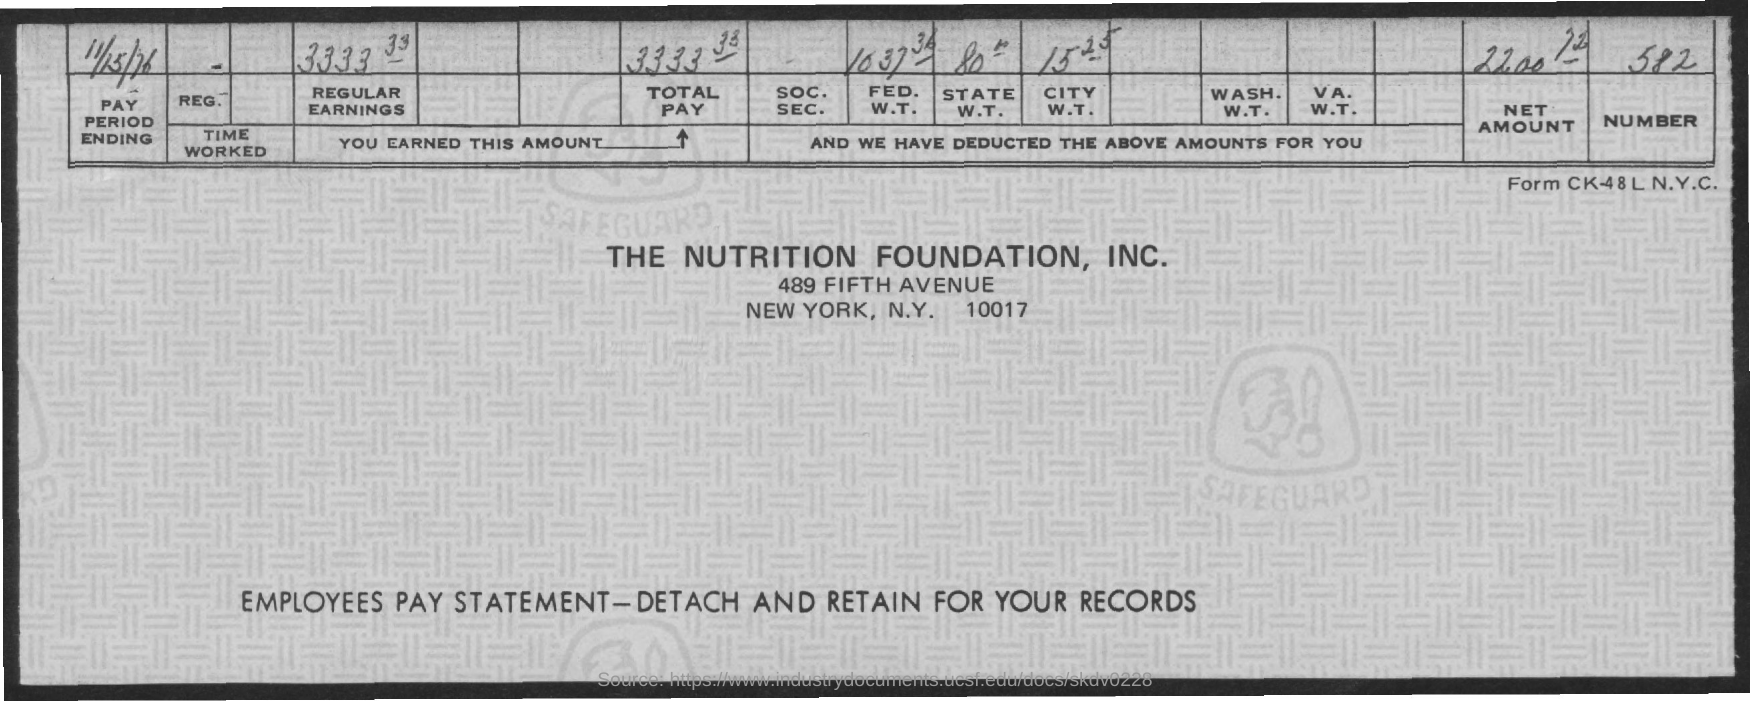What document is this?
Offer a very short reply. EMPLOYEES PAY STATEMENT. Payment is done by whom?
Your response must be concise. THE NUTRITION FOUNDATION,  INC. Which city is "THE NUTRITION FOUNDATION,  INC" located?
Ensure brevity in your answer.  NEW YORK. What is the ZIP code given in the address?
Your response must be concise. 10017. When is "PAY PERIOD ENDING"?
Make the answer very short. 11/15/76. What is the "NUMBER" mentioned in the PAY STATEMENT?
Provide a short and direct response. 582. 